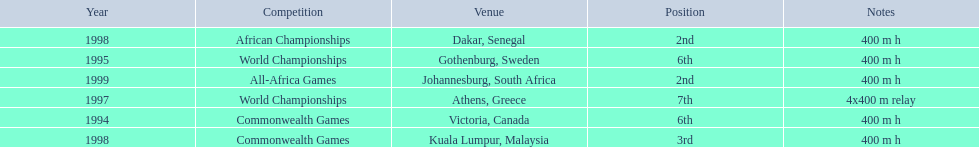What years did ken harder compete in? 1994, 1995, 1997, 1998, 1998, 1999. For the 1997 relay, what distance was ran? 4x400 m relay. 